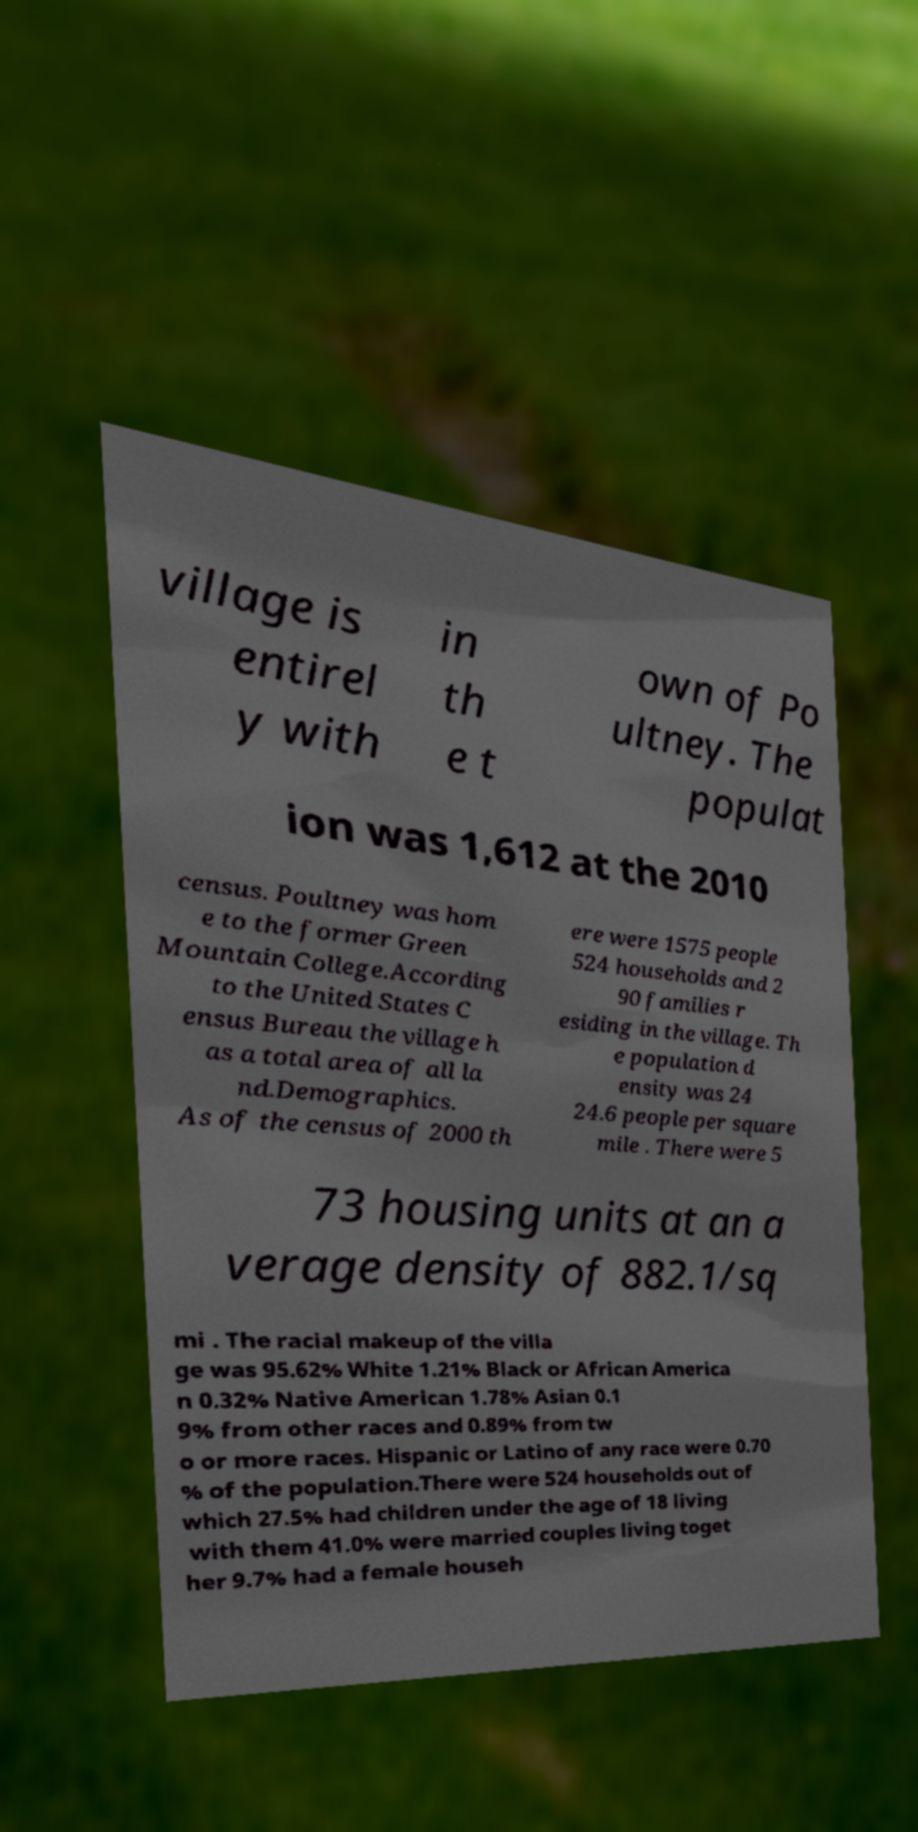Please read and relay the text visible in this image. What does it say? village is entirel y with in th e t own of Po ultney. The populat ion was 1,612 at the 2010 census. Poultney was hom e to the former Green Mountain College.According to the United States C ensus Bureau the village h as a total area of all la nd.Demographics. As of the census of 2000 th ere were 1575 people 524 households and 2 90 families r esiding in the village. Th e population d ensity was 24 24.6 people per square mile . There were 5 73 housing units at an a verage density of 882.1/sq mi . The racial makeup of the villa ge was 95.62% White 1.21% Black or African America n 0.32% Native American 1.78% Asian 0.1 9% from other races and 0.89% from tw o or more races. Hispanic or Latino of any race were 0.70 % of the population.There were 524 households out of which 27.5% had children under the age of 18 living with them 41.0% were married couples living toget her 9.7% had a female househ 